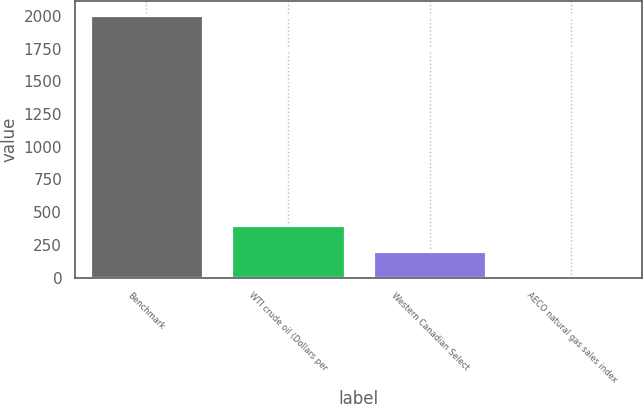<chart> <loc_0><loc_0><loc_500><loc_500><bar_chart><fcel>Benchmark<fcel>WTI crude oil (Dollars per<fcel>Western Canadian Select<fcel>AECO natural gas sales index<nl><fcel>2011<fcel>405.14<fcel>204.41<fcel>3.68<nl></chart> 